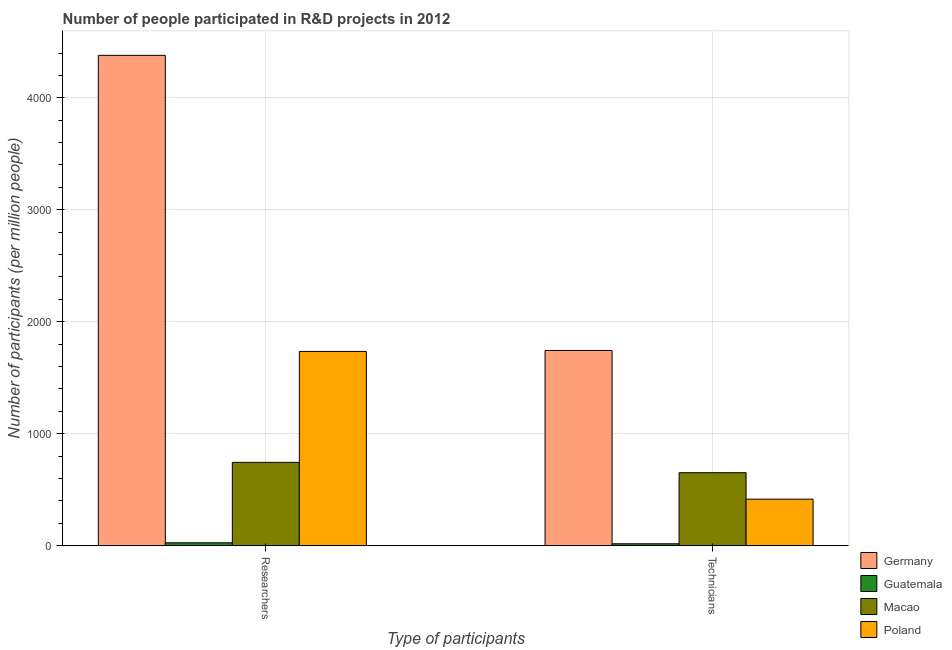How many different coloured bars are there?
Offer a terse response. 4. Are the number of bars on each tick of the X-axis equal?
Provide a short and direct response. Yes. How many bars are there on the 2nd tick from the right?
Provide a short and direct response. 4. What is the label of the 2nd group of bars from the left?
Provide a succinct answer. Technicians. What is the number of technicians in Germany?
Keep it short and to the point. 1743.9. Across all countries, what is the maximum number of technicians?
Give a very brief answer. 1743.9. Across all countries, what is the minimum number of technicians?
Keep it short and to the point. 17.96. In which country was the number of technicians minimum?
Provide a succinct answer. Guatemala. What is the total number of researchers in the graph?
Ensure brevity in your answer.  6886.1. What is the difference between the number of researchers in Guatemala and that in Macao?
Provide a short and direct response. -718.2. What is the difference between the number of technicians in Macao and the number of researchers in Poland?
Provide a succinct answer. -1082.74. What is the average number of technicians per country?
Your answer should be compact. 707.72. What is the difference between the number of technicians and number of researchers in Poland?
Provide a short and direct response. -1318.95. What is the ratio of the number of researchers in Guatemala to that in Macao?
Give a very brief answer. 0.04. Is the number of technicians in Macao less than that in Germany?
Ensure brevity in your answer.  Yes. In how many countries, is the number of technicians greater than the average number of technicians taken over all countries?
Provide a succinct answer. 1. What does the 1st bar from the right in Technicians represents?
Keep it short and to the point. Poland. How many bars are there?
Give a very brief answer. 8. Are all the bars in the graph horizontal?
Ensure brevity in your answer.  No. Are the values on the major ticks of Y-axis written in scientific E-notation?
Your answer should be very brief. No. How are the legend labels stacked?
Make the answer very short. Vertical. What is the title of the graph?
Ensure brevity in your answer.  Number of people participated in R&D projects in 2012. Does "Ecuador" appear as one of the legend labels in the graph?
Your answer should be compact. No. What is the label or title of the X-axis?
Keep it short and to the point. Type of participants. What is the label or title of the Y-axis?
Provide a short and direct response. Number of participants (per million people). What is the Number of participants (per million people) of Germany in Researchers?
Offer a terse response. 4379.08. What is the Number of participants (per million people) in Guatemala in Researchers?
Your answer should be very brief. 26.74. What is the Number of participants (per million people) in Macao in Researchers?
Provide a succinct answer. 744.94. What is the Number of participants (per million people) in Poland in Researchers?
Make the answer very short. 1735.35. What is the Number of participants (per million people) in Germany in Technicians?
Offer a terse response. 1743.9. What is the Number of participants (per million people) of Guatemala in Technicians?
Offer a terse response. 17.96. What is the Number of participants (per million people) of Macao in Technicians?
Make the answer very short. 652.61. What is the Number of participants (per million people) in Poland in Technicians?
Your answer should be compact. 416.4. Across all Type of participants, what is the maximum Number of participants (per million people) of Germany?
Your answer should be very brief. 4379.08. Across all Type of participants, what is the maximum Number of participants (per million people) of Guatemala?
Ensure brevity in your answer.  26.74. Across all Type of participants, what is the maximum Number of participants (per million people) in Macao?
Your answer should be compact. 744.94. Across all Type of participants, what is the maximum Number of participants (per million people) in Poland?
Keep it short and to the point. 1735.35. Across all Type of participants, what is the minimum Number of participants (per million people) in Germany?
Your answer should be compact. 1743.9. Across all Type of participants, what is the minimum Number of participants (per million people) of Guatemala?
Provide a short and direct response. 17.96. Across all Type of participants, what is the minimum Number of participants (per million people) in Macao?
Provide a short and direct response. 652.61. Across all Type of participants, what is the minimum Number of participants (per million people) in Poland?
Your answer should be very brief. 416.4. What is the total Number of participants (per million people) of Germany in the graph?
Give a very brief answer. 6122.98. What is the total Number of participants (per million people) of Guatemala in the graph?
Your answer should be very brief. 44.7. What is the total Number of participants (per million people) in Macao in the graph?
Offer a terse response. 1397.55. What is the total Number of participants (per million people) in Poland in the graph?
Offer a terse response. 2151.74. What is the difference between the Number of participants (per million people) of Germany in Researchers and that in Technicians?
Ensure brevity in your answer.  2635.17. What is the difference between the Number of participants (per million people) of Guatemala in Researchers and that in Technicians?
Make the answer very short. 8.78. What is the difference between the Number of participants (per million people) of Macao in Researchers and that in Technicians?
Your response must be concise. 92.33. What is the difference between the Number of participants (per million people) in Poland in Researchers and that in Technicians?
Provide a succinct answer. 1318.95. What is the difference between the Number of participants (per million people) in Germany in Researchers and the Number of participants (per million people) in Guatemala in Technicians?
Keep it short and to the point. 4361.12. What is the difference between the Number of participants (per million people) of Germany in Researchers and the Number of participants (per million people) of Macao in Technicians?
Provide a succinct answer. 3726.47. What is the difference between the Number of participants (per million people) in Germany in Researchers and the Number of participants (per million people) in Poland in Technicians?
Give a very brief answer. 3962.68. What is the difference between the Number of participants (per million people) of Guatemala in Researchers and the Number of participants (per million people) of Macao in Technicians?
Keep it short and to the point. -625.86. What is the difference between the Number of participants (per million people) in Guatemala in Researchers and the Number of participants (per million people) in Poland in Technicians?
Ensure brevity in your answer.  -389.66. What is the difference between the Number of participants (per million people) of Macao in Researchers and the Number of participants (per million people) of Poland in Technicians?
Your answer should be compact. 328.54. What is the average Number of participants (per million people) in Germany per Type of participants?
Your answer should be very brief. 3061.49. What is the average Number of participants (per million people) in Guatemala per Type of participants?
Keep it short and to the point. 22.35. What is the average Number of participants (per million people) of Macao per Type of participants?
Your answer should be compact. 698.77. What is the average Number of participants (per million people) in Poland per Type of participants?
Ensure brevity in your answer.  1075.87. What is the difference between the Number of participants (per million people) of Germany and Number of participants (per million people) of Guatemala in Researchers?
Provide a succinct answer. 4352.33. What is the difference between the Number of participants (per million people) of Germany and Number of participants (per million people) of Macao in Researchers?
Offer a very short reply. 3634.14. What is the difference between the Number of participants (per million people) of Germany and Number of participants (per million people) of Poland in Researchers?
Provide a short and direct response. 2643.73. What is the difference between the Number of participants (per million people) in Guatemala and Number of participants (per million people) in Macao in Researchers?
Ensure brevity in your answer.  -718.2. What is the difference between the Number of participants (per million people) of Guatemala and Number of participants (per million people) of Poland in Researchers?
Provide a succinct answer. -1708.6. What is the difference between the Number of participants (per million people) of Macao and Number of participants (per million people) of Poland in Researchers?
Ensure brevity in your answer.  -990.41. What is the difference between the Number of participants (per million people) in Germany and Number of participants (per million people) in Guatemala in Technicians?
Ensure brevity in your answer.  1725.95. What is the difference between the Number of participants (per million people) in Germany and Number of participants (per million people) in Macao in Technicians?
Your response must be concise. 1091.3. What is the difference between the Number of participants (per million people) of Germany and Number of participants (per million people) of Poland in Technicians?
Your response must be concise. 1327.51. What is the difference between the Number of participants (per million people) in Guatemala and Number of participants (per million people) in Macao in Technicians?
Ensure brevity in your answer.  -634.65. What is the difference between the Number of participants (per million people) of Guatemala and Number of participants (per million people) of Poland in Technicians?
Offer a terse response. -398.44. What is the difference between the Number of participants (per million people) of Macao and Number of participants (per million people) of Poland in Technicians?
Provide a short and direct response. 236.21. What is the ratio of the Number of participants (per million people) in Germany in Researchers to that in Technicians?
Give a very brief answer. 2.51. What is the ratio of the Number of participants (per million people) of Guatemala in Researchers to that in Technicians?
Provide a short and direct response. 1.49. What is the ratio of the Number of participants (per million people) of Macao in Researchers to that in Technicians?
Provide a short and direct response. 1.14. What is the ratio of the Number of participants (per million people) in Poland in Researchers to that in Technicians?
Offer a terse response. 4.17. What is the difference between the highest and the second highest Number of participants (per million people) in Germany?
Ensure brevity in your answer.  2635.17. What is the difference between the highest and the second highest Number of participants (per million people) of Guatemala?
Keep it short and to the point. 8.78. What is the difference between the highest and the second highest Number of participants (per million people) of Macao?
Keep it short and to the point. 92.33. What is the difference between the highest and the second highest Number of participants (per million people) of Poland?
Offer a very short reply. 1318.95. What is the difference between the highest and the lowest Number of participants (per million people) of Germany?
Offer a terse response. 2635.17. What is the difference between the highest and the lowest Number of participants (per million people) in Guatemala?
Ensure brevity in your answer.  8.78. What is the difference between the highest and the lowest Number of participants (per million people) in Macao?
Keep it short and to the point. 92.33. What is the difference between the highest and the lowest Number of participants (per million people) of Poland?
Make the answer very short. 1318.95. 